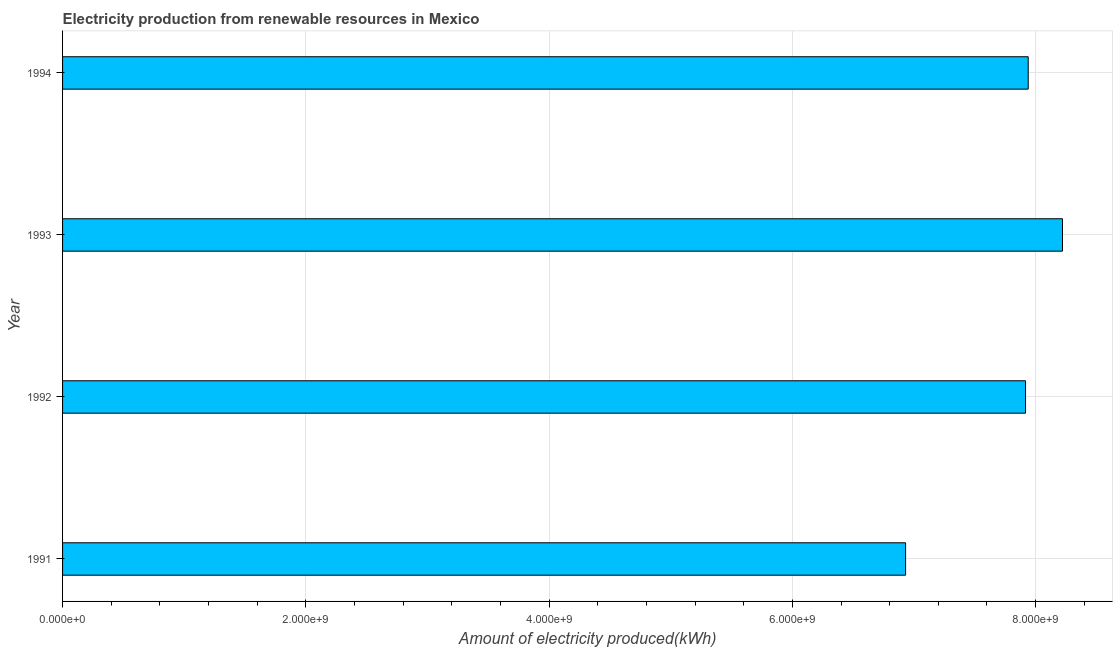Does the graph contain any zero values?
Give a very brief answer. No. Does the graph contain grids?
Keep it short and to the point. Yes. What is the title of the graph?
Your response must be concise. Electricity production from renewable resources in Mexico. What is the label or title of the X-axis?
Keep it short and to the point. Amount of electricity produced(kWh). What is the label or title of the Y-axis?
Ensure brevity in your answer.  Year. What is the amount of electricity produced in 1993?
Make the answer very short. 8.22e+09. Across all years, what is the maximum amount of electricity produced?
Give a very brief answer. 8.22e+09. Across all years, what is the minimum amount of electricity produced?
Provide a short and direct response. 6.93e+09. In which year was the amount of electricity produced minimum?
Your response must be concise. 1991. What is the sum of the amount of electricity produced?
Give a very brief answer. 3.10e+1. What is the difference between the amount of electricity produced in 1991 and 1994?
Provide a short and direct response. -1.01e+09. What is the average amount of electricity produced per year?
Your response must be concise. 7.75e+09. What is the median amount of electricity produced?
Keep it short and to the point. 7.93e+09. What is the ratio of the amount of electricity produced in 1991 to that in 1992?
Give a very brief answer. 0.88. Is the amount of electricity produced in 1991 less than that in 1992?
Make the answer very short. Yes. What is the difference between the highest and the second highest amount of electricity produced?
Your answer should be compact. 2.82e+08. What is the difference between the highest and the lowest amount of electricity produced?
Ensure brevity in your answer.  1.29e+09. How many bars are there?
Your answer should be very brief. 4. What is the difference between two consecutive major ticks on the X-axis?
Make the answer very short. 2.00e+09. What is the Amount of electricity produced(kWh) in 1991?
Provide a short and direct response. 6.93e+09. What is the Amount of electricity produced(kWh) of 1992?
Keep it short and to the point. 7.92e+09. What is the Amount of electricity produced(kWh) of 1993?
Make the answer very short. 8.22e+09. What is the Amount of electricity produced(kWh) of 1994?
Keep it short and to the point. 7.94e+09. What is the difference between the Amount of electricity produced(kWh) in 1991 and 1992?
Offer a terse response. -9.86e+08. What is the difference between the Amount of electricity produced(kWh) in 1991 and 1993?
Give a very brief answer. -1.29e+09. What is the difference between the Amount of electricity produced(kWh) in 1991 and 1994?
Offer a terse response. -1.01e+09. What is the difference between the Amount of electricity produced(kWh) in 1992 and 1993?
Give a very brief answer. -3.04e+08. What is the difference between the Amount of electricity produced(kWh) in 1992 and 1994?
Your answer should be compact. -2.20e+07. What is the difference between the Amount of electricity produced(kWh) in 1993 and 1994?
Give a very brief answer. 2.82e+08. What is the ratio of the Amount of electricity produced(kWh) in 1991 to that in 1992?
Keep it short and to the point. 0.88. What is the ratio of the Amount of electricity produced(kWh) in 1991 to that in 1993?
Keep it short and to the point. 0.84. What is the ratio of the Amount of electricity produced(kWh) in 1991 to that in 1994?
Ensure brevity in your answer.  0.87. What is the ratio of the Amount of electricity produced(kWh) in 1992 to that in 1994?
Give a very brief answer. 1. What is the ratio of the Amount of electricity produced(kWh) in 1993 to that in 1994?
Keep it short and to the point. 1.04. 